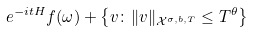Convert formula to latex. <formula><loc_0><loc_0><loc_500><loc_500>e ^ { - i t H } f ( \omega ) + \left \{ v \colon \| v \| _ { \mathcal { X } ^ { \sigma , b , T } } \leq T ^ { \theta } \right \}</formula> 